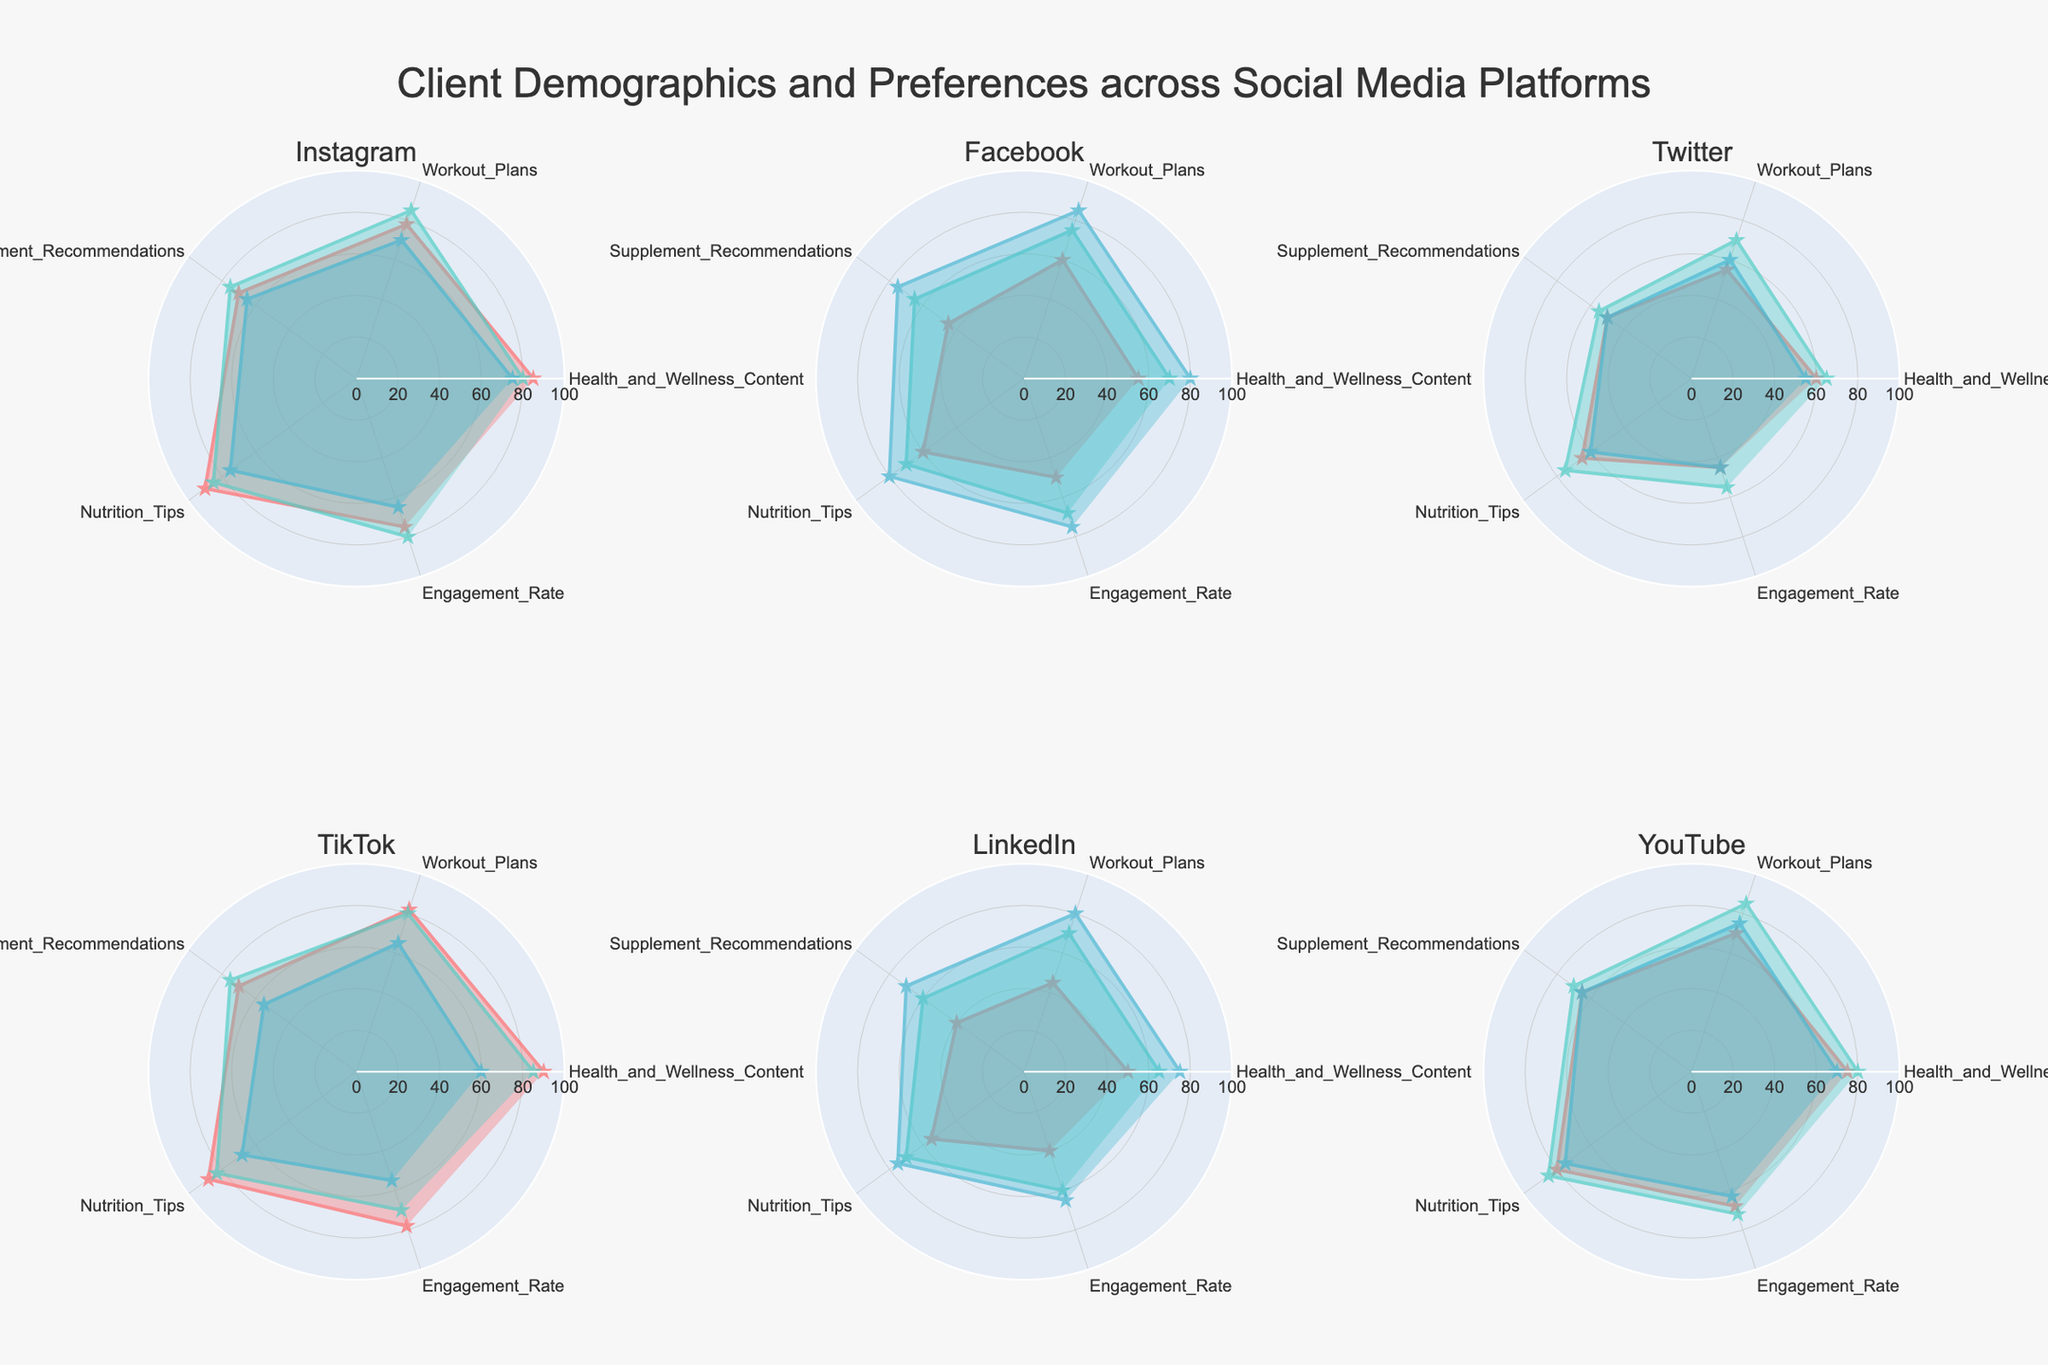how many platforms are visualized in the figure? the subplot titles indicate six different social media platforms: Instagram, Facebook, Twitter, TikTok, LinkedIn, YouTube
Answer: six Which age group has the highest engagement rate across any platform? By visually scanning the radar plots, "TikTok - 18-24" has the highest engagement rate of 78.
Answer: TikTok - 18-24 What is the average engagement rate for Facebook users across all age groups? For Facebook: 18-24 has 50, 25-34 has 68, and 35-44 has 75. Average = (50 + 68 + 75) / 3 = 64.33
Answer: 64.33 Which platforms tend to have higher health and wellness content scores for the 18-24 age group compared to others? By inspecting the radar plots, "TikTok - 18-24" and "Instagram - 18-24" both score higher than other platforms within the same age group
Answer: TikTok, Instagram What is the range of nutrition tips score for the 25-34 age group across all platforms? The scores are: Instagram=85, Facebook=70, Twitter=75, TikTok=83, LinkedIn=70, YouTube=85. The range = 85 - 70 = 15
Answer: 15 Which platform has the most consistent preferences in workout plans across all age groups? By looking at the radar charts, LinkedIn shows consistent values (45, 70, 80) for workout plans across age groups
Answer: LinkedIn Which age group on Instagram shows the least interest in supplement recommendations? The radar chart indicates "Instagram - 35-44" has the lowest value for supplement recommendations with a score of 65.
Answer: 35-44 Do Instagram users of the same age group have higher engagement rates than Facebook users? Comparing each age group radar chart between Instagram and Facebook: 18-24 (Instagram: 75, Facebook: 50), 25-34 (Instagram: 80, Facebook: 68), 35-44 (Instagram: 65, Facebook: 75).
Answer: Not for all age groups How do TikTok and YouTube compare in terms of nutrition tips for the 18-24 age group? Inspect the radar charts for both platforms: TikTok scores 88, whereas YouTube scores 80
Answer: TikTok - higher 